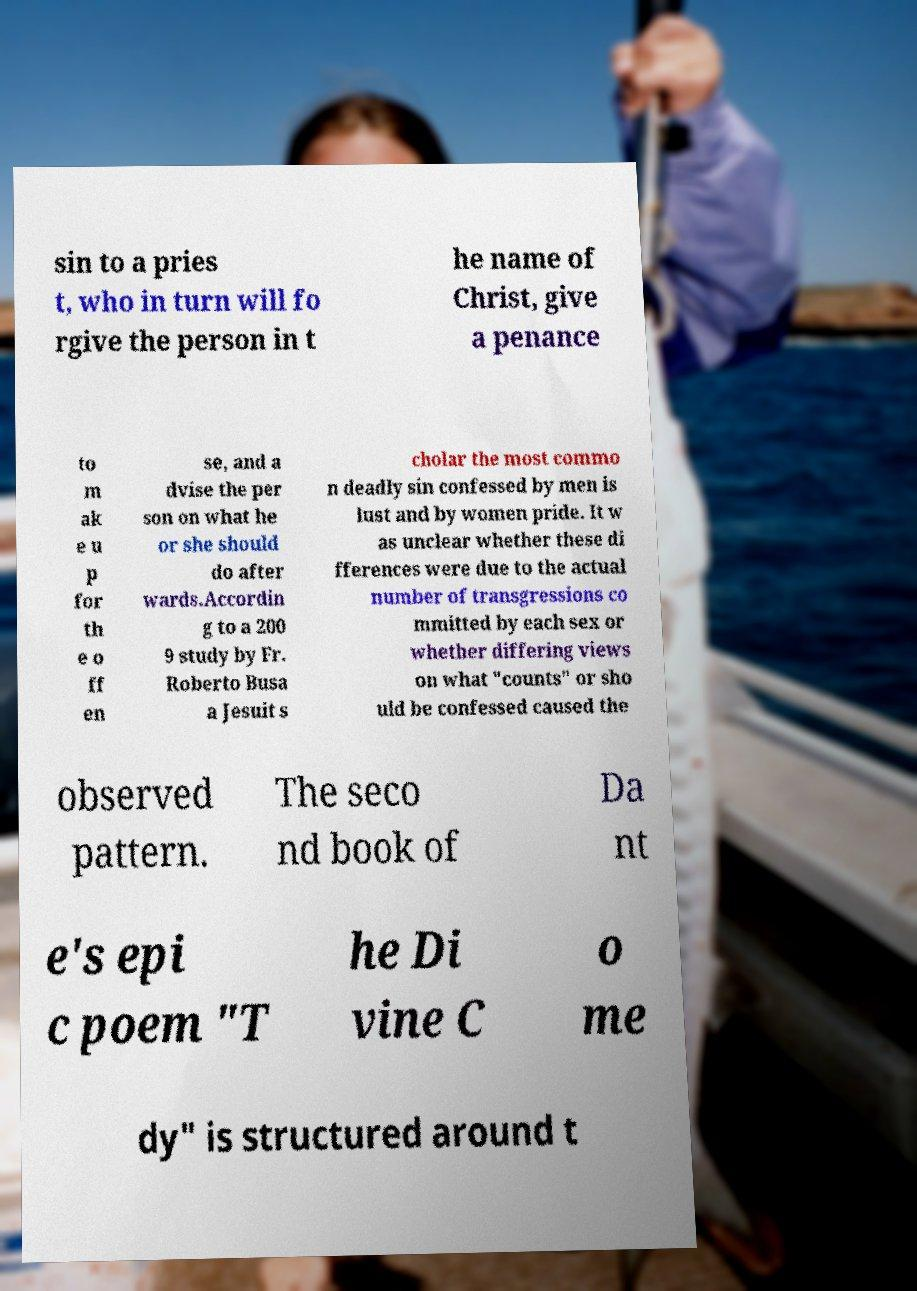Please identify and transcribe the text found in this image. sin to a pries t, who in turn will fo rgive the person in t he name of Christ, give a penance to m ak e u p for th e o ff en se, and a dvise the per son on what he or she should do after wards.Accordin g to a 200 9 study by Fr. Roberto Busa a Jesuit s cholar the most commo n deadly sin confessed by men is lust and by women pride. It w as unclear whether these di fferences were due to the actual number of transgressions co mmitted by each sex or whether differing views on what "counts" or sho uld be confessed caused the observed pattern. The seco nd book of Da nt e's epi c poem "T he Di vine C o me dy" is structured around t 